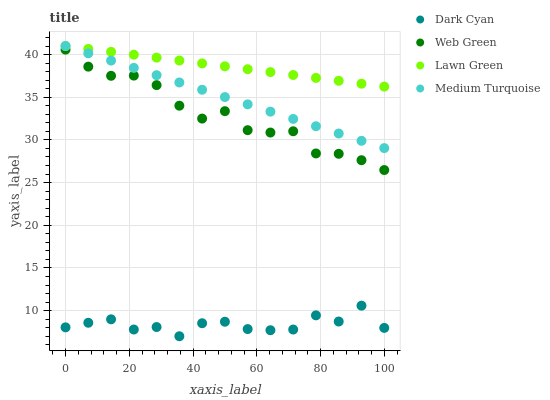Does Dark Cyan have the minimum area under the curve?
Answer yes or no. Yes. Does Lawn Green have the maximum area under the curve?
Answer yes or no. Yes. Does Medium Turquoise have the minimum area under the curve?
Answer yes or no. No. Does Medium Turquoise have the maximum area under the curve?
Answer yes or no. No. Is Medium Turquoise the smoothest?
Answer yes or no. Yes. Is Dark Cyan the roughest?
Answer yes or no. Yes. Is Lawn Green the smoothest?
Answer yes or no. No. Is Lawn Green the roughest?
Answer yes or no. No. Does Dark Cyan have the lowest value?
Answer yes or no. Yes. Does Medium Turquoise have the lowest value?
Answer yes or no. No. Does Medium Turquoise have the highest value?
Answer yes or no. Yes. Does Web Green have the highest value?
Answer yes or no. No. Is Dark Cyan less than Lawn Green?
Answer yes or no. Yes. Is Lawn Green greater than Dark Cyan?
Answer yes or no. Yes. Does Lawn Green intersect Medium Turquoise?
Answer yes or no. Yes. Is Lawn Green less than Medium Turquoise?
Answer yes or no. No. Is Lawn Green greater than Medium Turquoise?
Answer yes or no. No. Does Dark Cyan intersect Lawn Green?
Answer yes or no. No. 